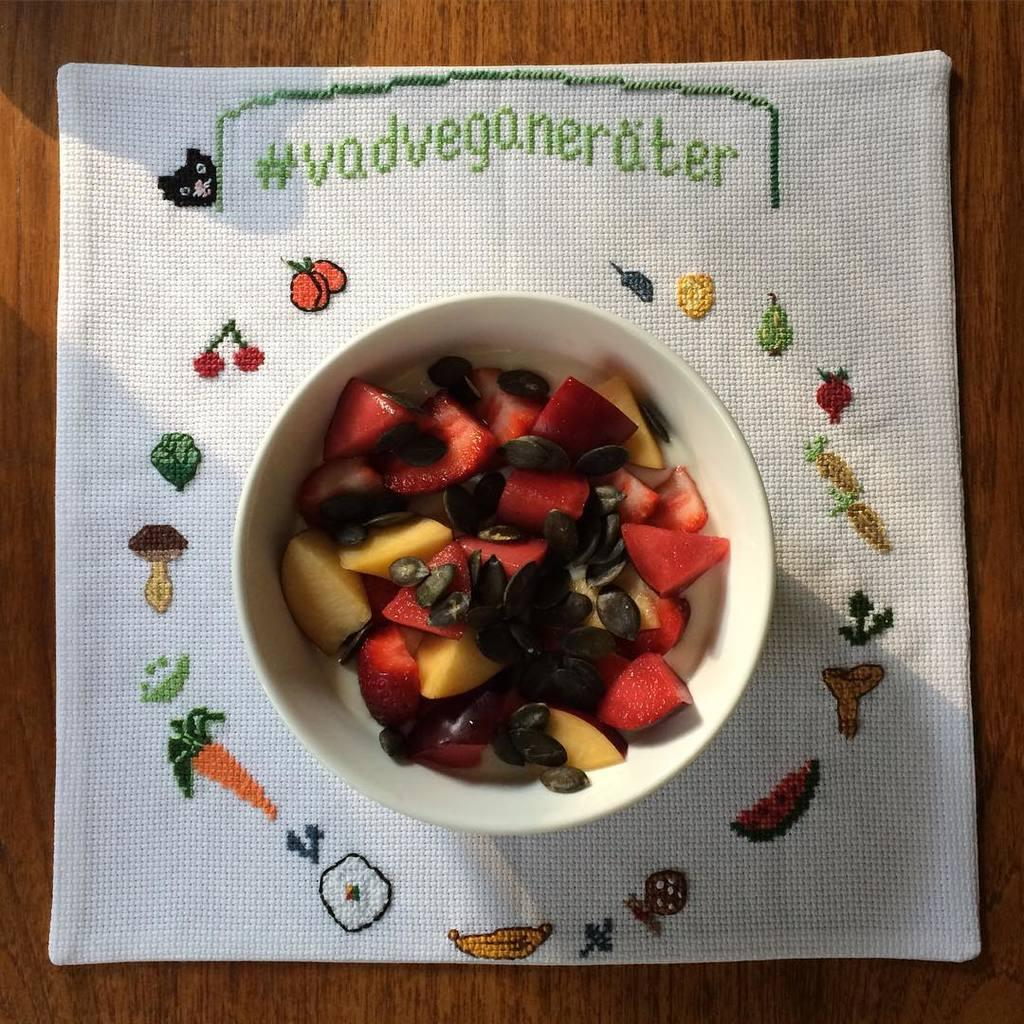What is in the bowl that is visible in the image? There are fruits in a bowl in the image. What else can be seen on the table in the image? There is a cloth on the table in the image. What channel is the fly watching on the table in the image? There is no fly or television present in the image. 